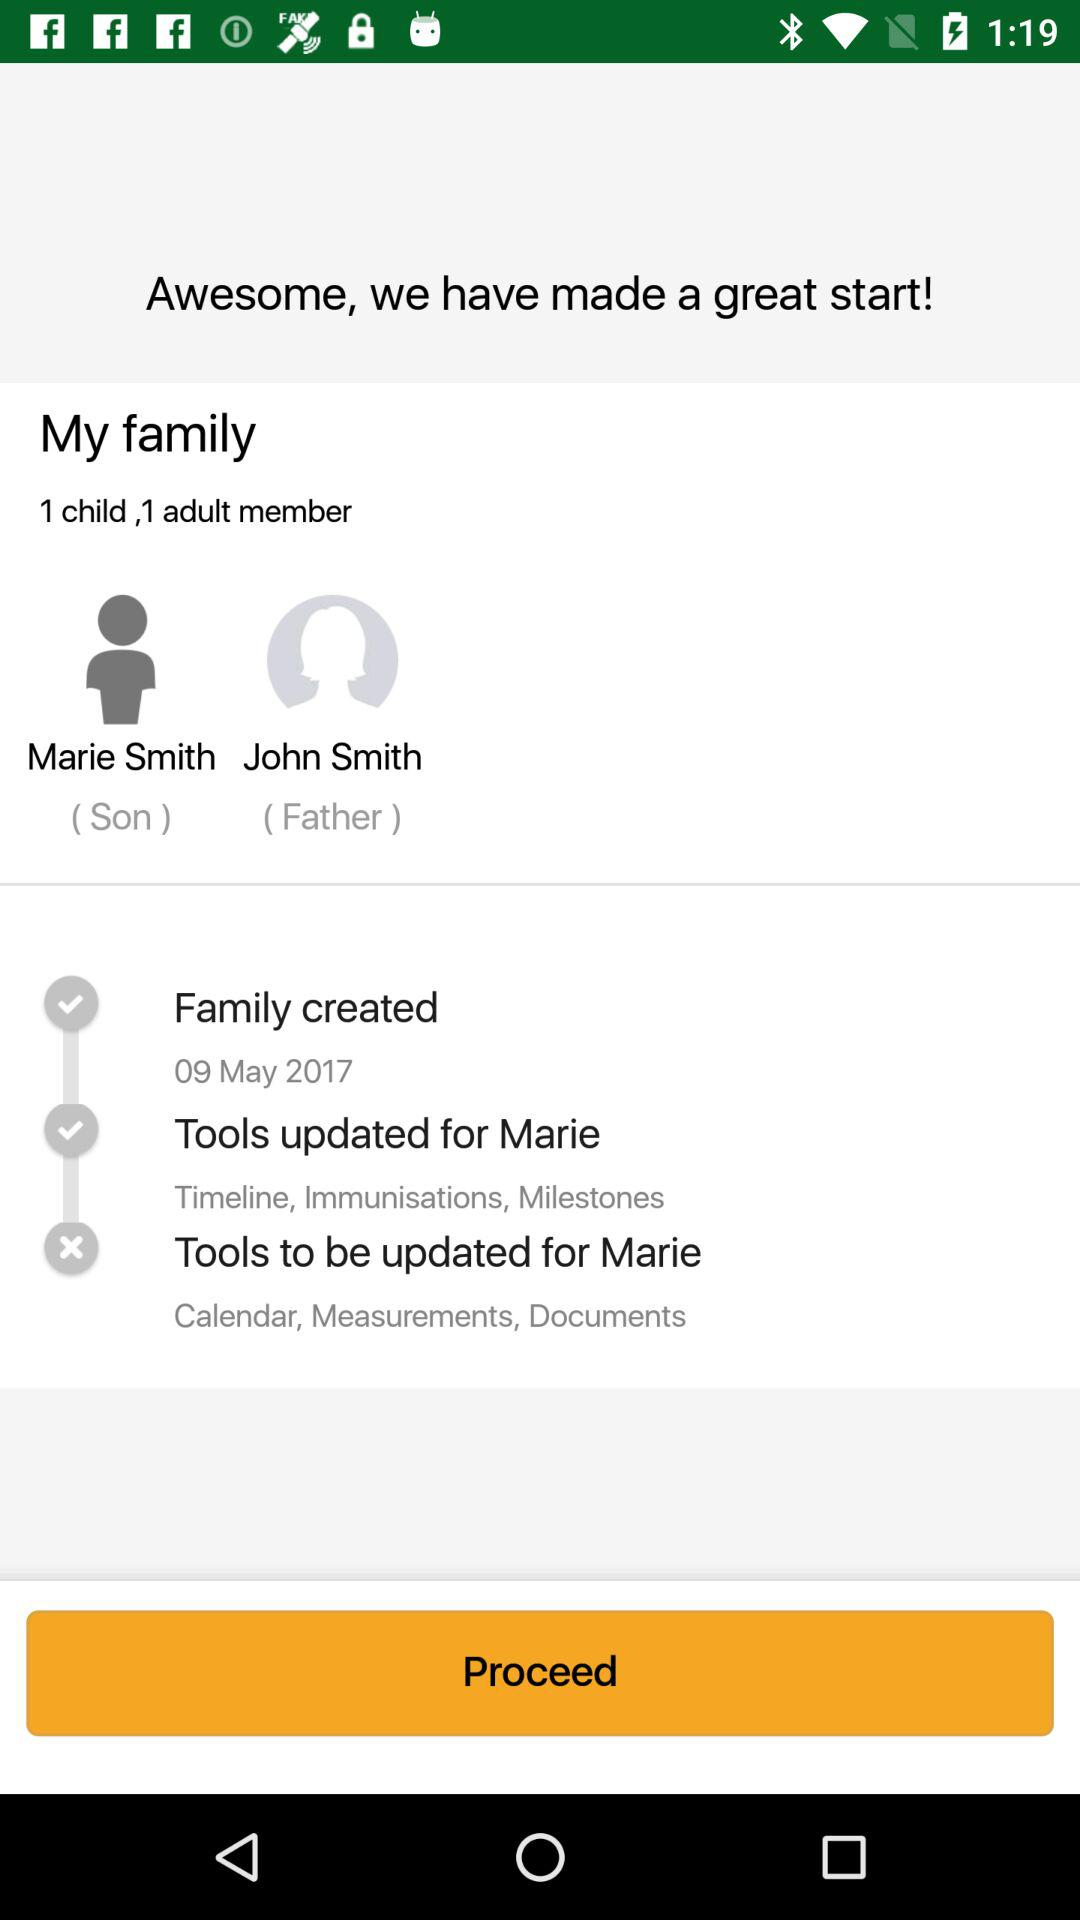What is the father's name? The father's name is John Smith. 